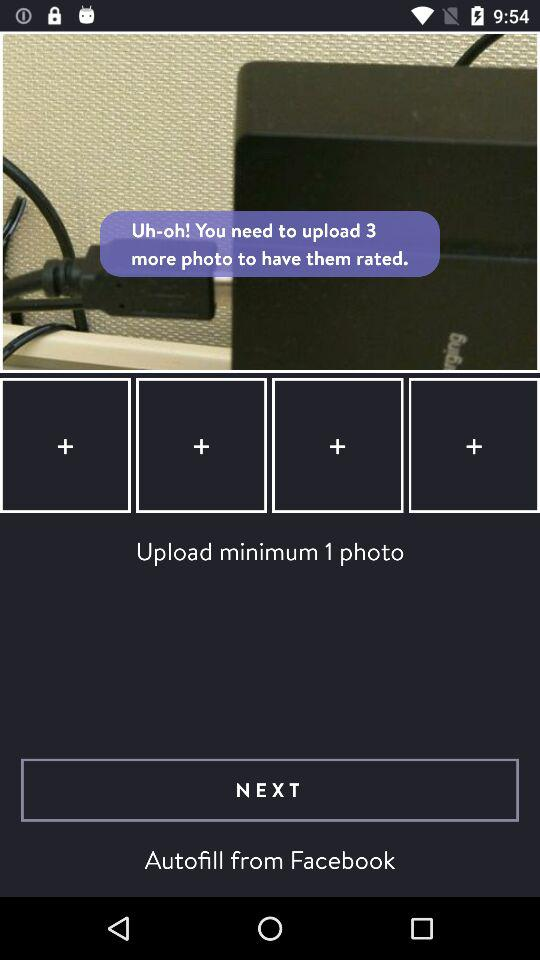How many minimum photos need to be uploaded? The minimum number of photos that need to be uploaded is 3. 